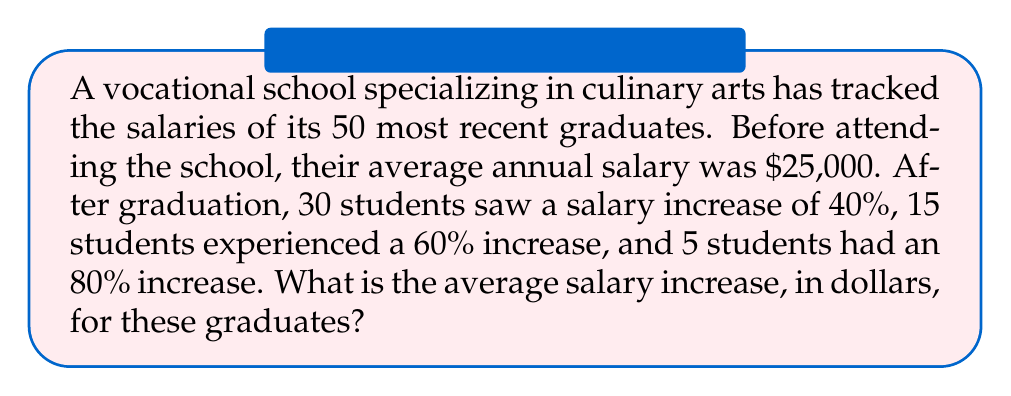Teach me how to tackle this problem. Let's approach this step-by-step:

1) First, let's calculate the salary increase for each group:

   40% increase: $25,000 \times 0.40 = $10,000
   60% increase: $25,000 \times 0.60 = $15,000
   80% increase: $25,000 \times 0.80 = $20,000

2) Now, let's calculate the total increase for each group:

   30 students with $10,000 increase: $30 \times 10,000 = $300,000
   15 students with $15,000 increase: $15 \times 15,000 = $225,000
   5 students with $20,000 increase: $5 \times 20,000 = $100,000

3) Let's sum up the total increase:

   Total increase = $300,000 + $225,000 + $100,000 = $625,000

4) To find the average increase, we divide the total increase by the number of students:

   Average increase = $\frac{\text{Total increase}}{\text{Number of students}}$

   $$ \text{Average increase} = \frac{\$625,000}{50} = \$12,500 $$

Therefore, the average salary increase for these graduates is $12,500.
Answer: $12,500 